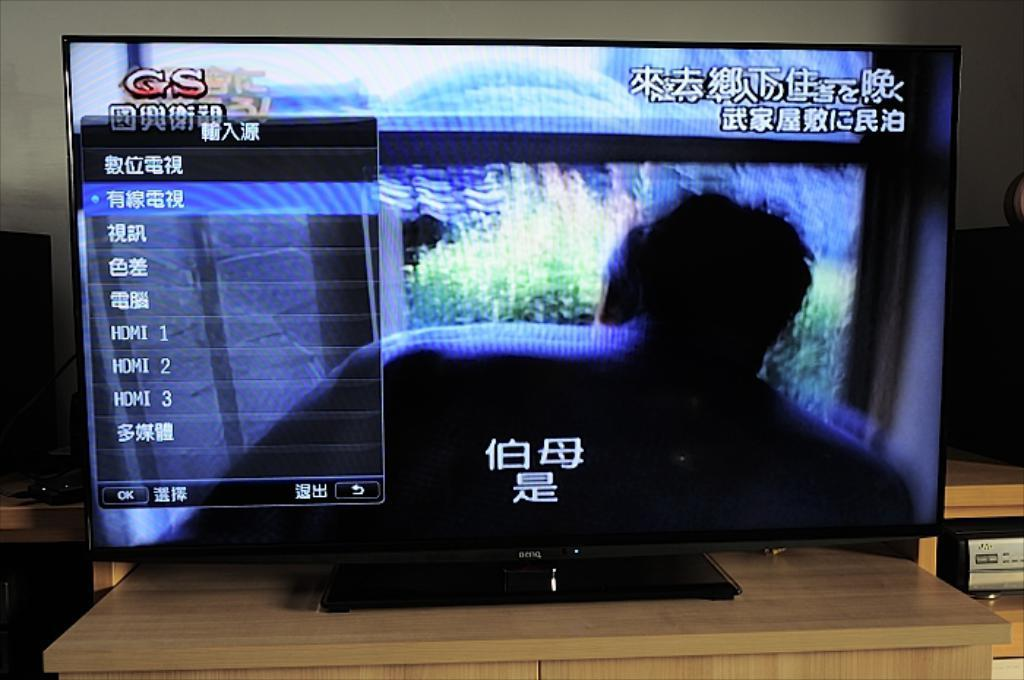Provide a one-sentence caption for the provided image. Gs is in red letters on the top left of the screen. 